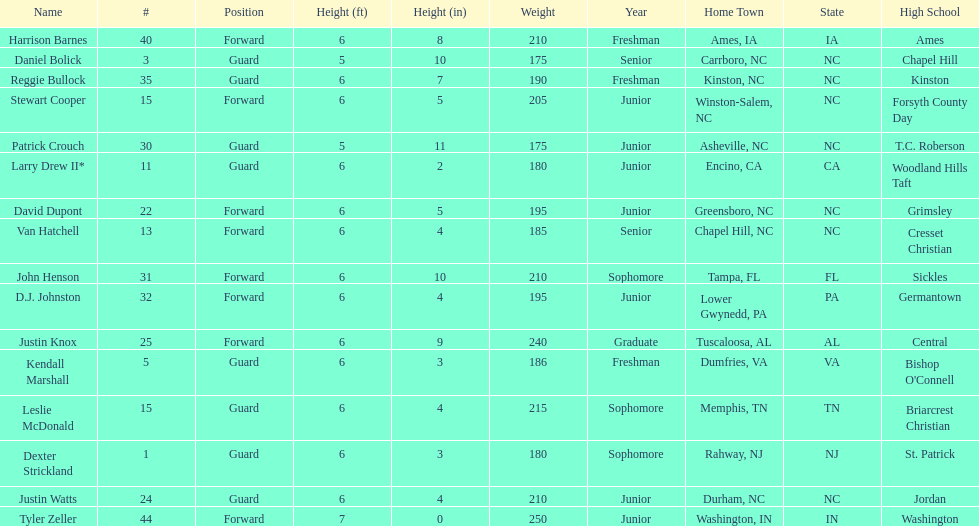How many players play a position other than guard? 8. 